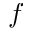<formula> <loc_0><loc_0><loc_500><loc_500>f</formula> 